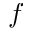<formula> <loc_0><loc_0><loc_500><loc_500>f</formula> 